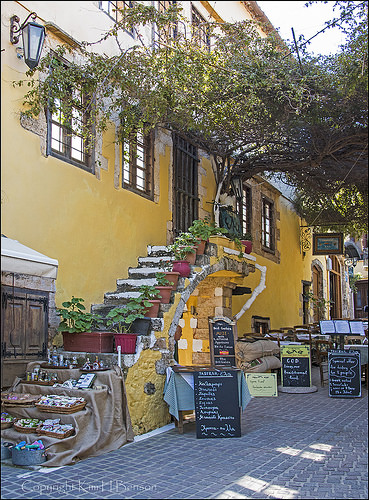<image>
Can you confirm if the tree is next to the stairs? Yes. The tree is positioned adjacent to the stairs, located nearby in the same general area. 